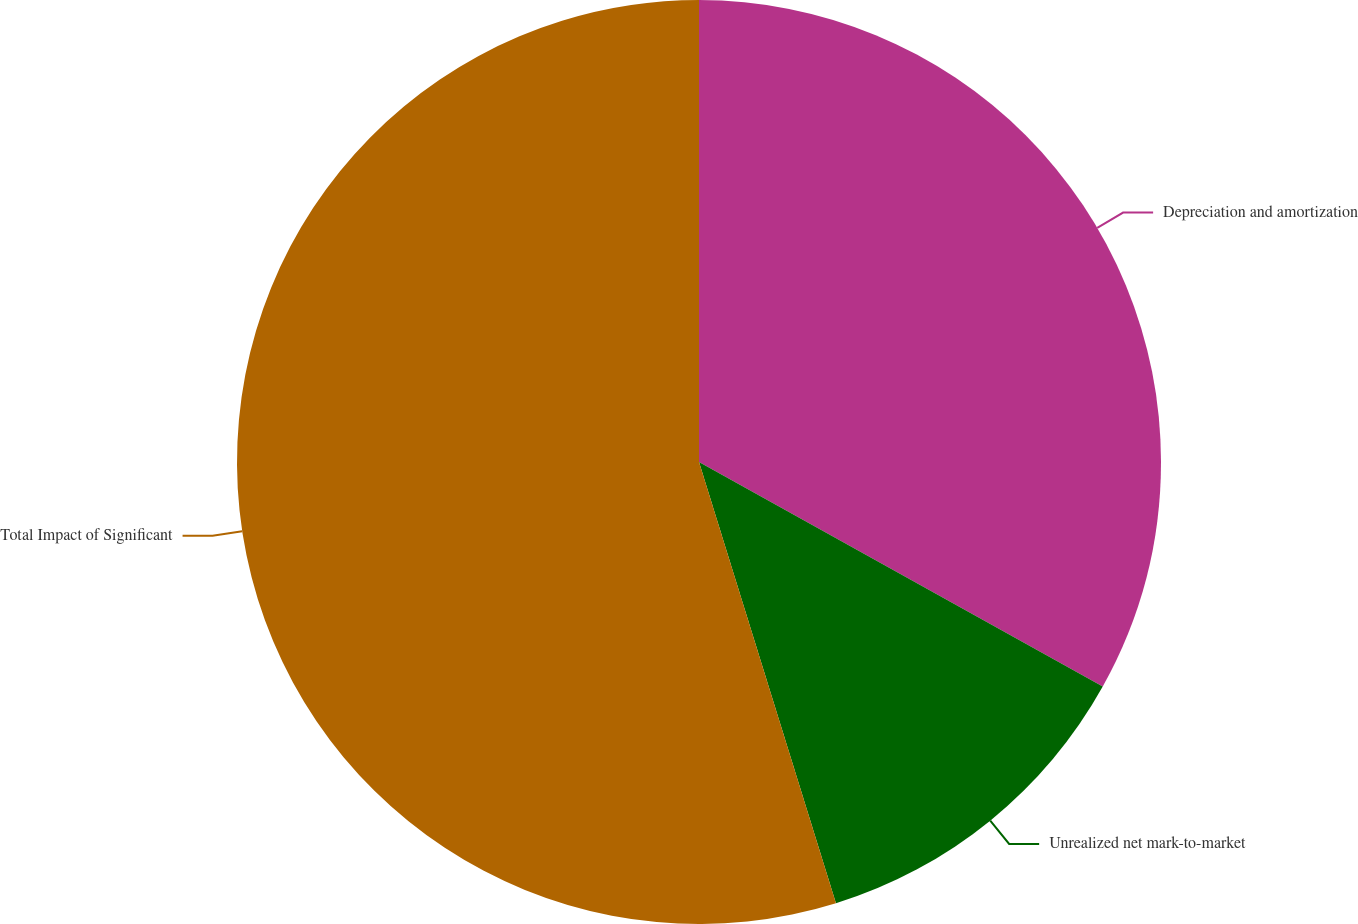Convert chart. <chart><loc_0><loc_0><loc_500><loc_500><pie_chart><fcel>Depreciation and amortization<fcel>Unrealized net mark-to-market<fcel>Total Impact of Significant<nl><fcel>33.08%<fcel>12.13%<fcel>54.79%<nl></chart> 